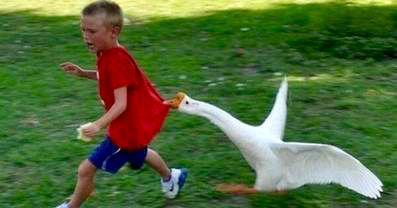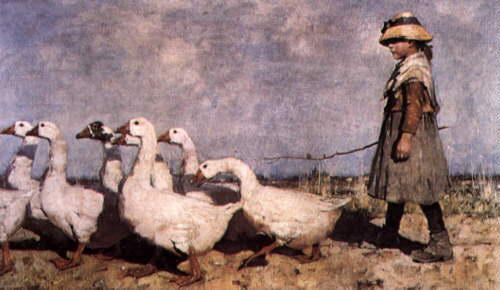The first image is the image on the left, the second image is the image on the right. For the images displayed, is the sentence "An image contains a goose attacking a child." factually correct? Answer yes or no. Yes. The first image is the image on the left, the second image is the image on the right. Given the left and right images, does the statement "The left image shows a child running near a white goose with wings spread, and the right image shows a girl in a dress holding something and standing by multiple geese." hold true? Answer yes or no. Yes. The first image is the image on the left, the second image is the image on the right. For the images displayed, is the sentence "This a goose white white belly trying to bite a small scared child." factually correct? Answer yes or no. Yes. 